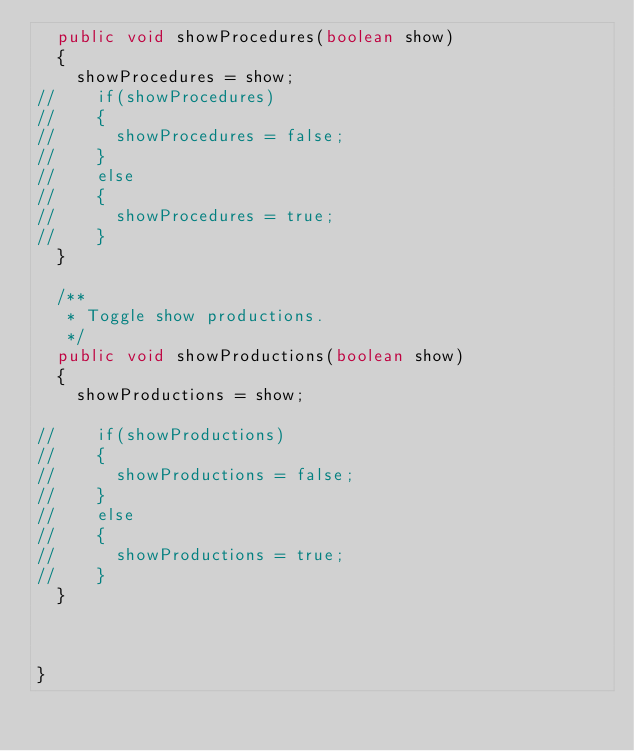Convert code to text. <code><loc_0><loc_0><loc_500><loc_500><_Java_>	public void showProcedures(boolean show) 
	{
		showProcedures = show;
//		if(showProcedures)
//		{
//			showProcedures = false;
//		}
//		else
//		{
//			showProcedures = true;
//		}
	}

	/**
	 * Toggle show productions.
	 */
	public void showProductions(boolean show) 
	{
		showProductions = show;
		
//		if(showProductions)
//		{
//			showProductions = false;
//		}
//		else
//		{
//			showProductions = true;
//		}
	}
	
	

}
</code> 